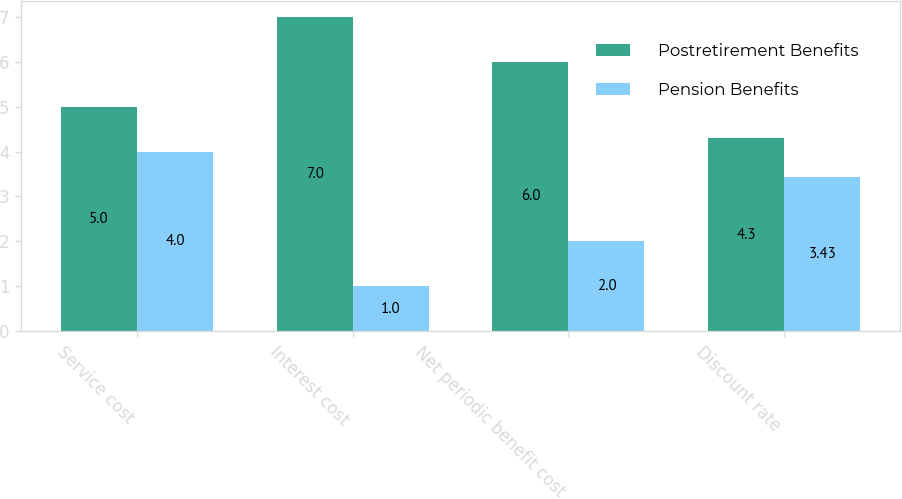<chart> <loc_0><loc_0><loc_500><loc_500><stacked_bar_chart><ecel><fcel>Service cost<fcel>Interest cost<fcel>Net periodic benefit cost<fcel>Discount rate<nl><fcel>Postretirement Benefits<fcel>5<fcel>7<fcel>6<fcel>4.3<nl><fcel>Pension Benefits<fcel>4<fcel>1<fcel>2<fcel>3.43<nl></chart> 